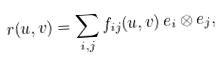<formula> <loc_0><loc_0><loc_500><loc_500>r ( u , v ) = \sum _ { i , j } f _ { i j } ( u , v ) \, e _ { i } \otimes e _ { j } ,</formula> 